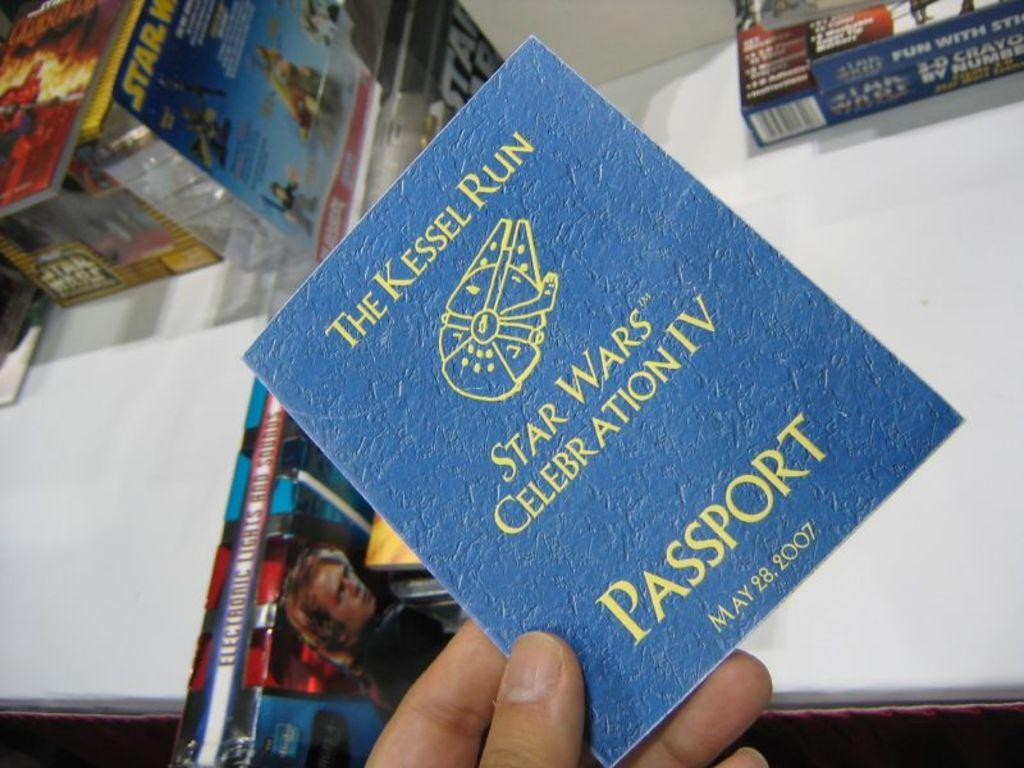<image>
Describe the image concisely. The invitation to the Star Wars celebration IV on 05/28/07 was made to look like a passport. 